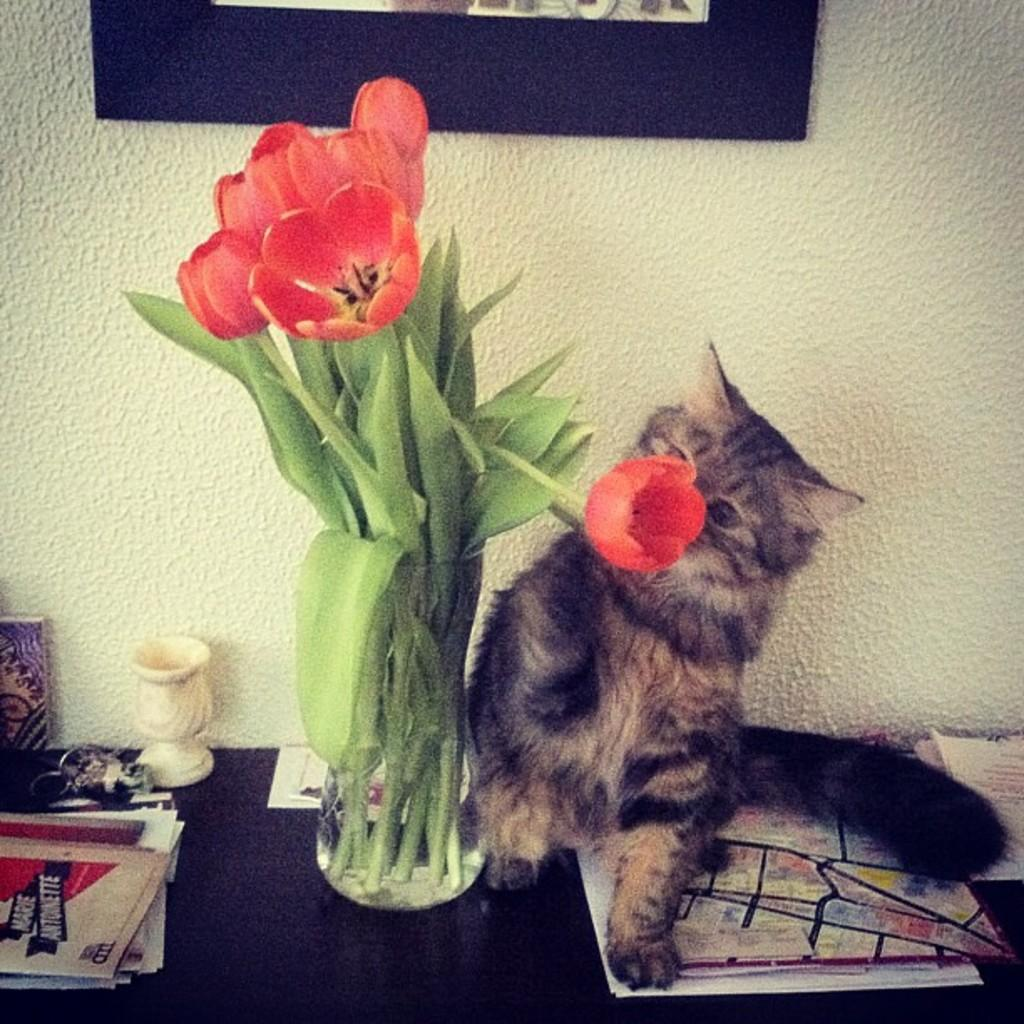What type of animal can be seen in the image? There is a cat in the image. What is the cat sitting near in the image? There is a flower vase in the image. What can be found on the table in the image? There are books and other objects on the table in the image. What is hanging on the wall in the image? There is a frame hanging on the wall in the image. What type of vessel is the father using to carry the bears in the image? There is no father, vessel, or bears present in the image. 